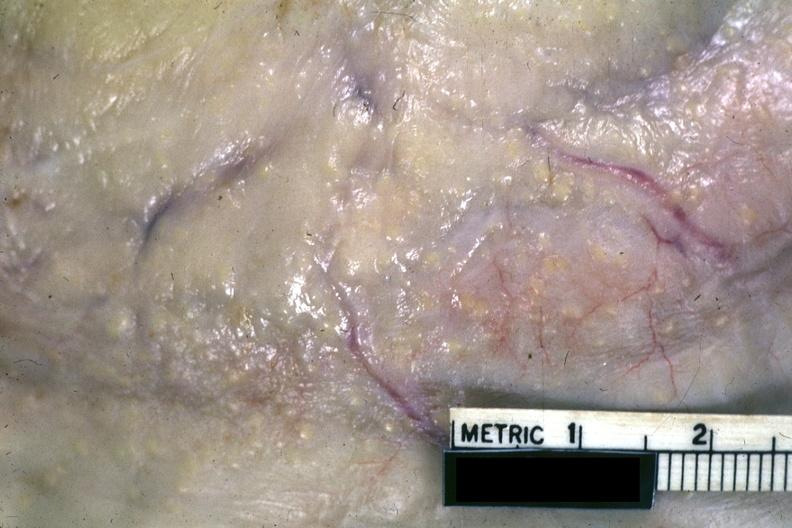what is present?
Answer the question using a single word or phrase. Tuberculous peritonitis 